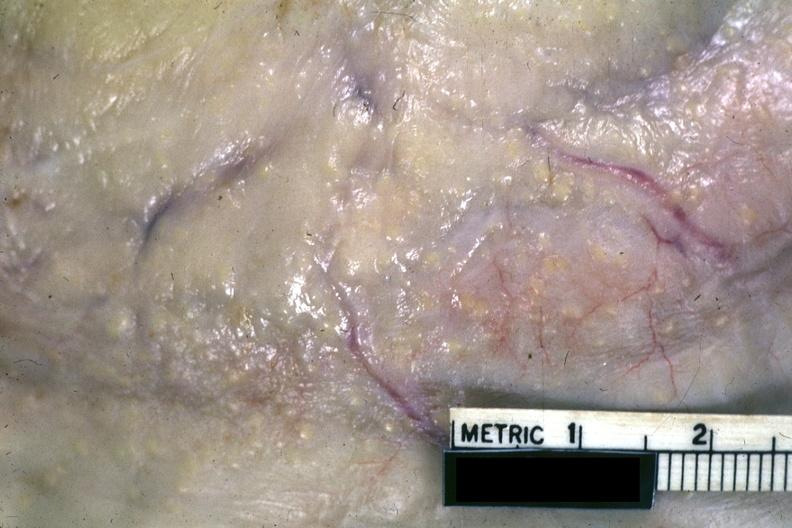what is present?
Answer the question using a single word or phrase. Tuberculous peritonitis 